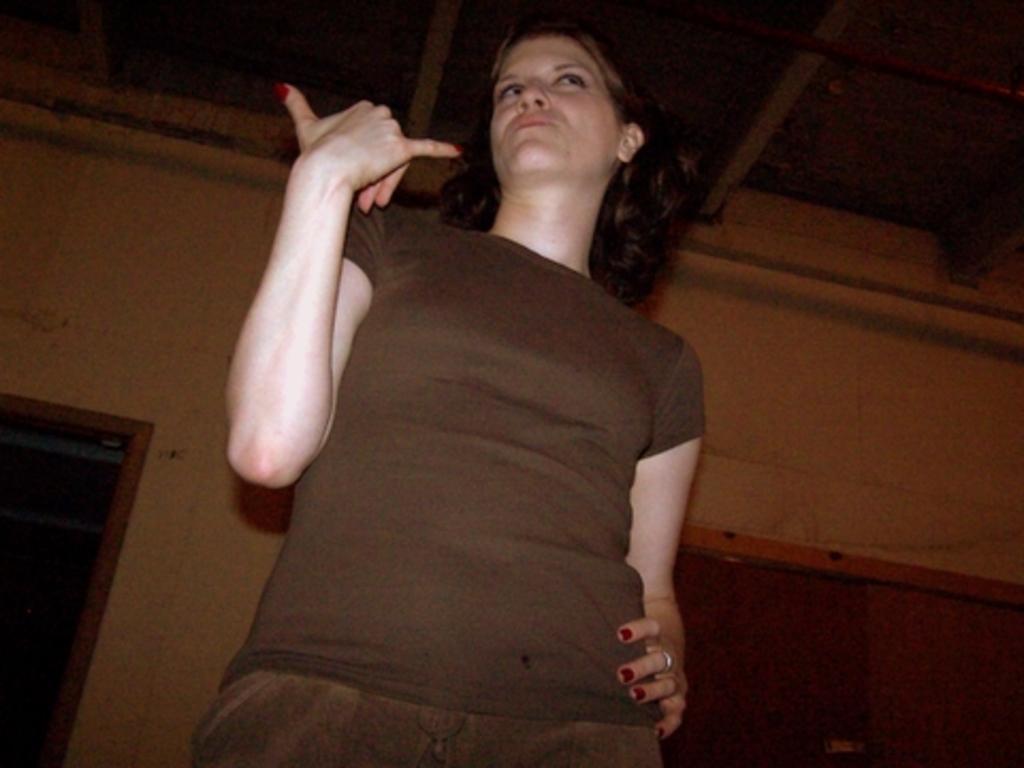Please provide a concise description of this image. In this image, we can see a woman standing, we can see the wall and a door. 